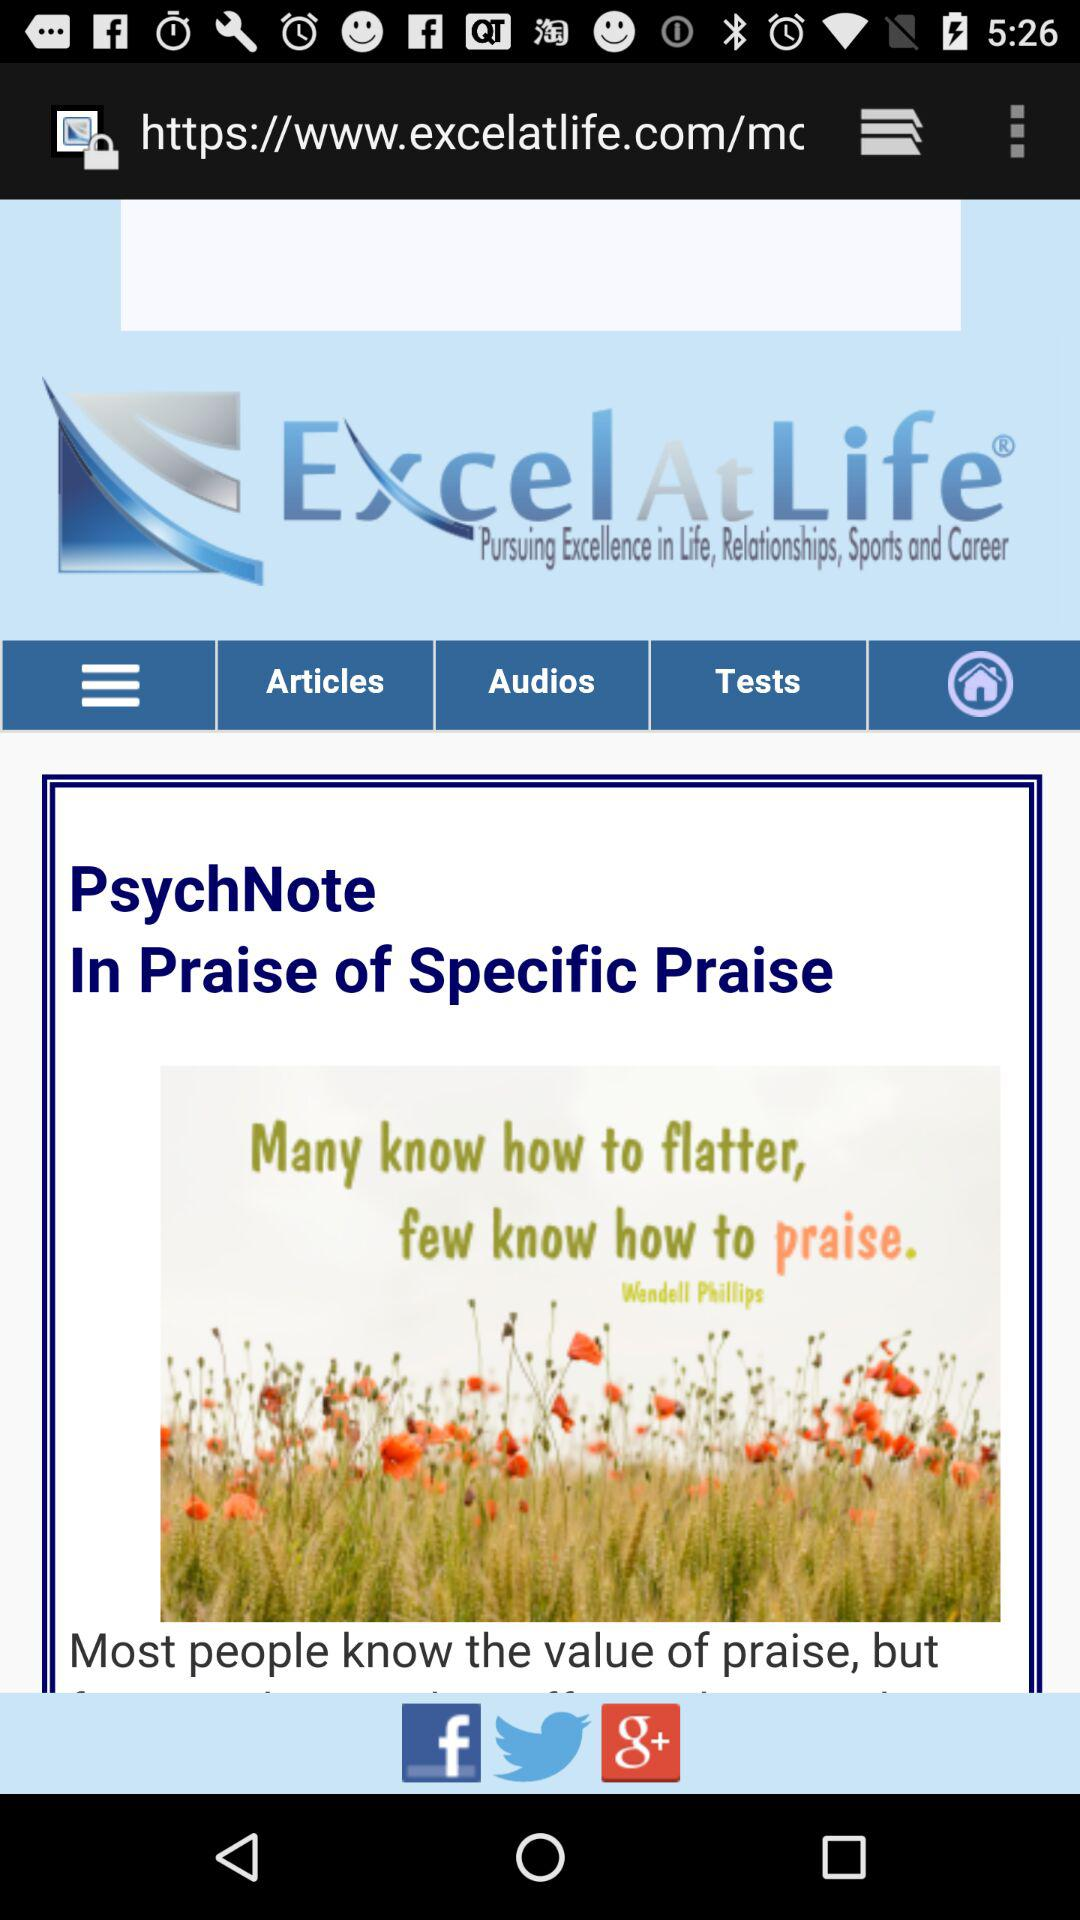What is the application name? The application name is "Excel At Life". 